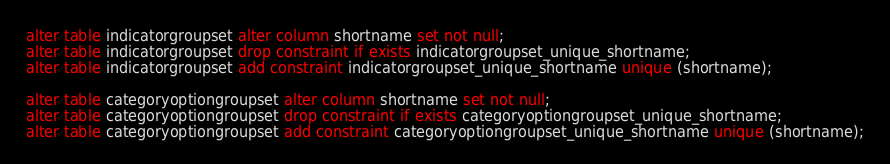Convert code to text. <code><loc_0><loc_0><loc_500><loc_500><_SQL_>alter table indicatorgroupset alter column shortname set not null;
alter table indicatorgroupset drop constraint if exists indicatorgroupset_unique_shortname;
alter table indicatorgroupset add constraint indicatorgroupset_unique_shortname unique (shortname);

alter table categoryoptiongroupset alter column shortname set not null;
alter table categoryoptiongroupset drop constraint if exists categoryoptiongroupset_unique_shortname;
alter table categoryoptiongroupset add constraint categoryoptiongroupset_unique_shortname unique (shortname);
</code> 